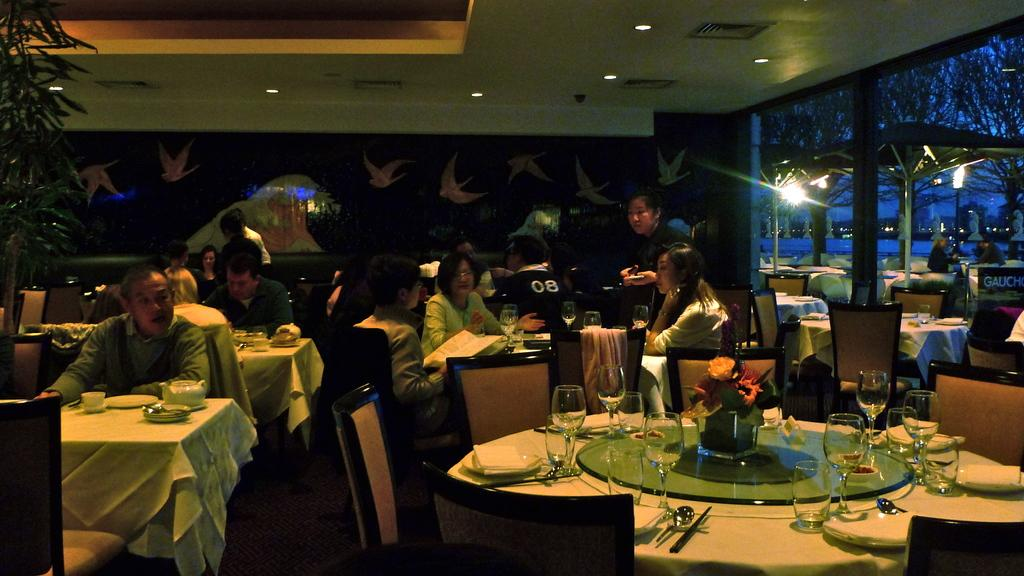How many people are in the image? There is a group of people in the image. Where are the people located in the image? The people are sitting in a restaurant. What type of error did the governor make in the image? There is no governor or error present in the image. 